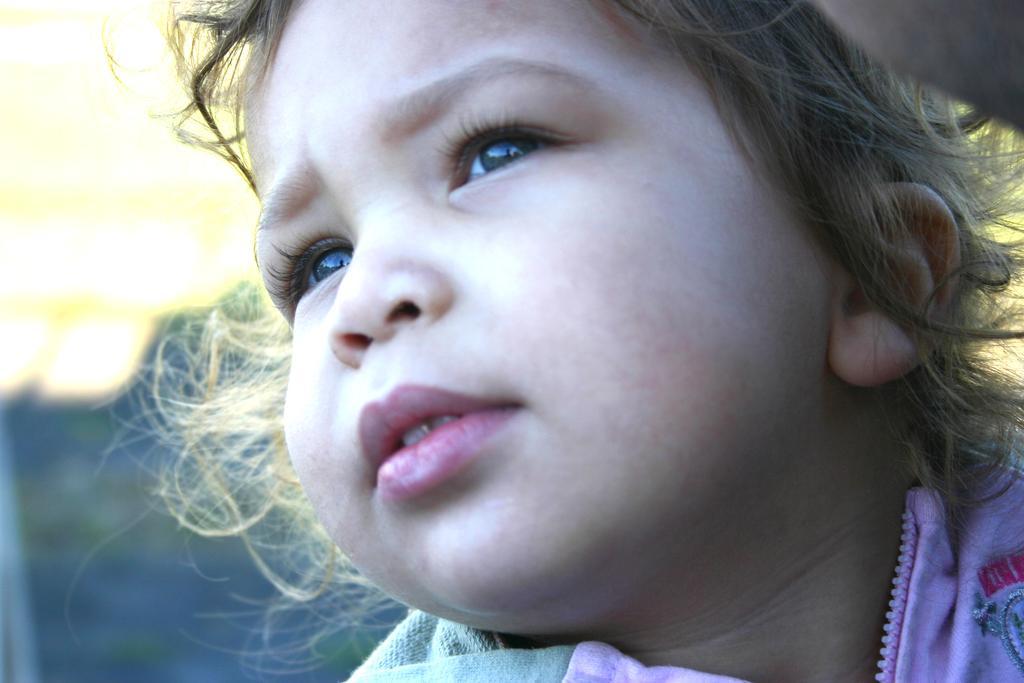Can you describe this image briefly? In this image we can see the face of a child. 